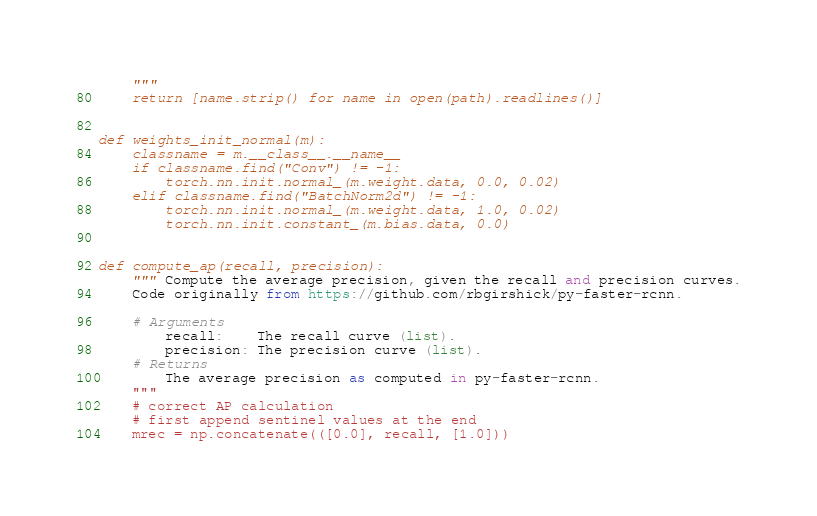<code> <loc_0><loc_0><loc_500><loc_500><_Python_>    """
    return [name.strip() for name in open(path).readlines()]


def weights_init_normal(m):
    classname = m.__class__.__name__
    if classname.find("Conv") != -1:
        torch.nn.init.normal_(m.weight.data, 0.0, 0.02)
    elif classname.find("BatchNorm2d") != -1:
        torch.nn.init.normal_(m.weight.data, 1.0, 0.02)
        torch.nn.init.constant_(m.bias.data, 0.0)


def compute_ap(recall, precision):
    """ Compute the average precision, given the recall and precision curves.
    Code originally from https://github.com/rbgirshick/py-faster-rcnn.

    # Arguments
        recall:    The recall curve (list).
        precision: The precision curve (list).
    # Returns
        The average precision as computed in py-faster-rcnn.
    """
    # correct AP calculation
    # first append sentinel values at the end
    mrec = np.concatenate(([0.0], recall, [1.0]))</code> 